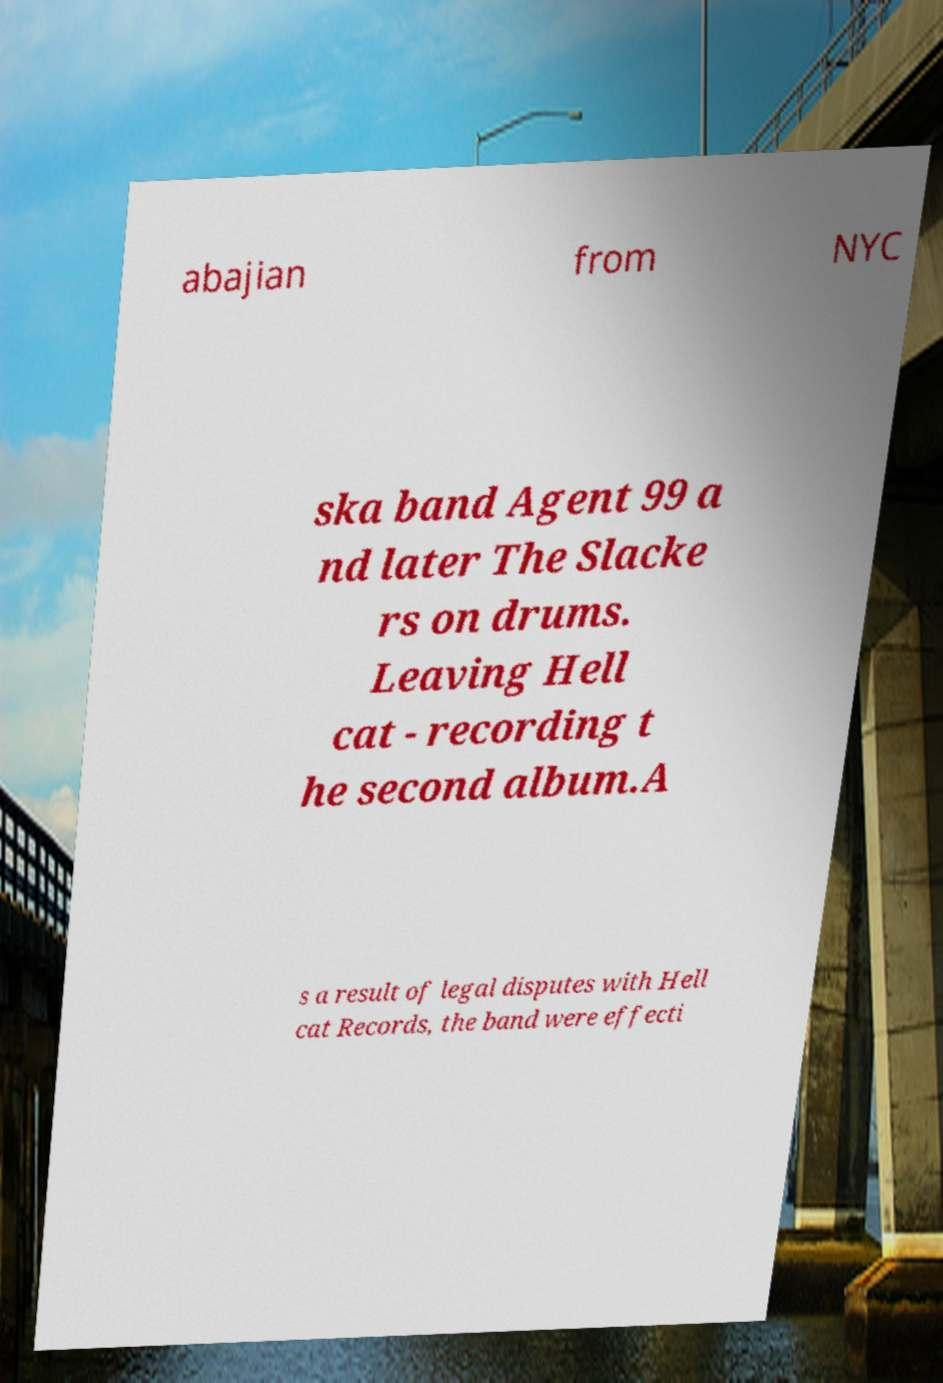Could you extract and type out the text from this image? abajian from NYC ska band Agent 99 a nd later The Slacke rs on drums. Leaving Hell cat - recording t he second album.A s a result of legal disputes with Hell cat Records, the band were effecti 